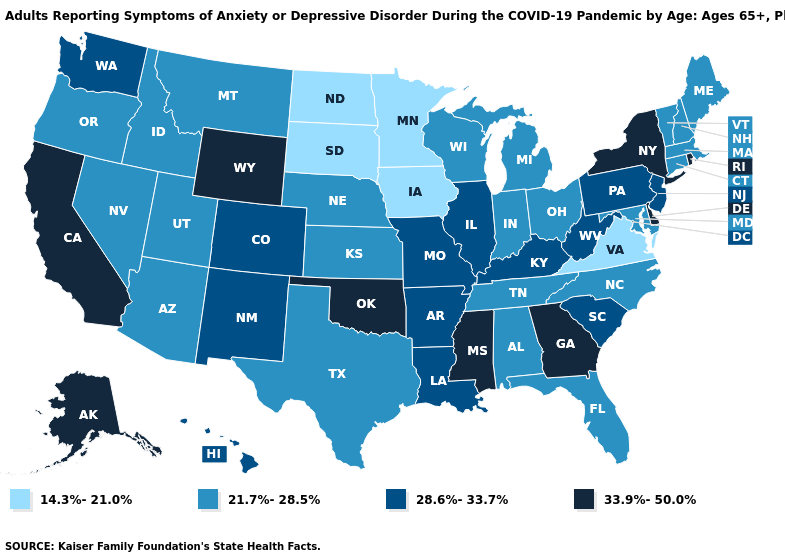What is the value of Mississippi?
Answer briefly. 33.9%-50.0%. What is the value of Utah?
Concise answer only. 21.7%-28.5%. Does South Dakota have the lowest value in the USA?
Answer briefly. Yes. Does the map have missing data?
Give a very brief answer. No. What is the value of New Jersey?
Concise answer only. 28.6%-33.7%. Which states have the highest value in the USA?
Be succinct. Alaska, California, Delaware, Georgia, Mississippi, New York, Oklahoma, Rhode Island, Wyoming. What is the lowest value in the MidWest?
Write a very short answer. 14.3%-21.0%. What is the lowest value in states that border Rhode Island?
Give a very brief answer. 21.7%-28.5%. Name the states that have a value in the range 28.6%-33.7%?
Be succinct. Arkansas, Colorado, Hawaii, Illinois, Kentucky, Louisiana, Missouri, New Jersey, New Mexico, Pennsylvania, South Carolina, Washington, West Virginia. Name the states that have a value in the range 21.7%-28.5%?
Quick response, please. Alabama, Arizona, Connecticut, Florida, Idaho, Indiana, Kansas, Maine, Maryland, Massachusetts, Michigan, Montana, Nebraska, Nevada, New Hampshire, North Carolina, Ohio, Oregon, Tennessee, Texas, Utah, Vermont, Wisconsin. What is the lowest value in the Northeast?
Answer briefly. 21.7%-28.5%. Which states hav the highest value in the South?
Be succinct. Delaware, Georgia, Mississippi, Oklahoma. What is the value of Wyoming?
Write a very short answer. 33.9%-50.0%. What is the value of Oklahoma?
Be succinct. 33.9%-50.0%. Which states have the lowest value in the USA?
Concise answer only. Iowa, Minnesota, North Dakota, South Dakota, Virginia. 